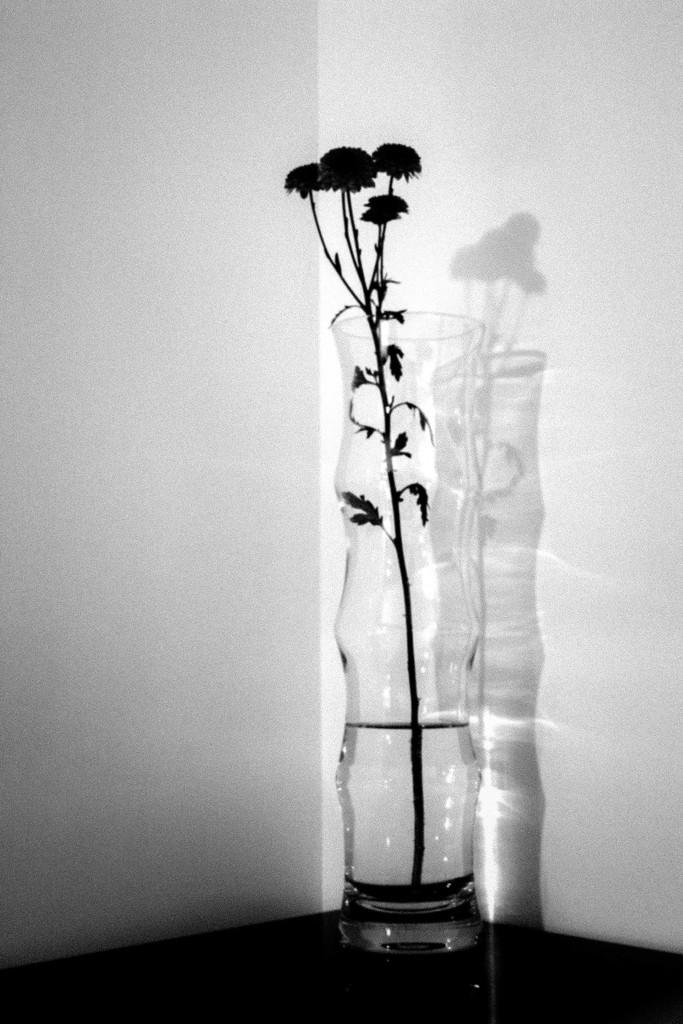In one or two sentences, can you explain what this image depicts? In this image I can see the flower vase. In the background I can see the wall and this is a black and white image. 